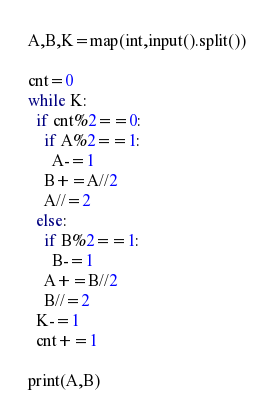Convert code to text. <code><loc_0><loc_0><loc_500><loc_500><_Python_>A,B,K=map(int,input().split())

cnt=0
while K:
  if cnt%2==0:
    if A%2==1:
      A-=1
    B+=A//2
    A//=2
  else:
    if B%2==1:
      B-=1
    A+=B//2
    B//=2  
  K-=1
  cnt+=1
  
print(A,B)</code> 